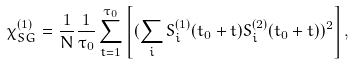<formula> <loc_0><loc_0><loc_500><loc_500>\chi _ { S G } ^ { ( 1 ) } = \frac { 1 } { N } \frac { 1 } { \tau _ { 0 } } \sum _ { t = 1 } ^ { \tau _ { 0 } } \left [ ( \sum _ { i } S _ { i } ^ { ( 1 ) } ( t _ { 0 } + t ) S _ { i } ^ { ( 2 ) } ( t _ { 0 } + t ) ) ^ { 2 } \right ] ,</formula> 